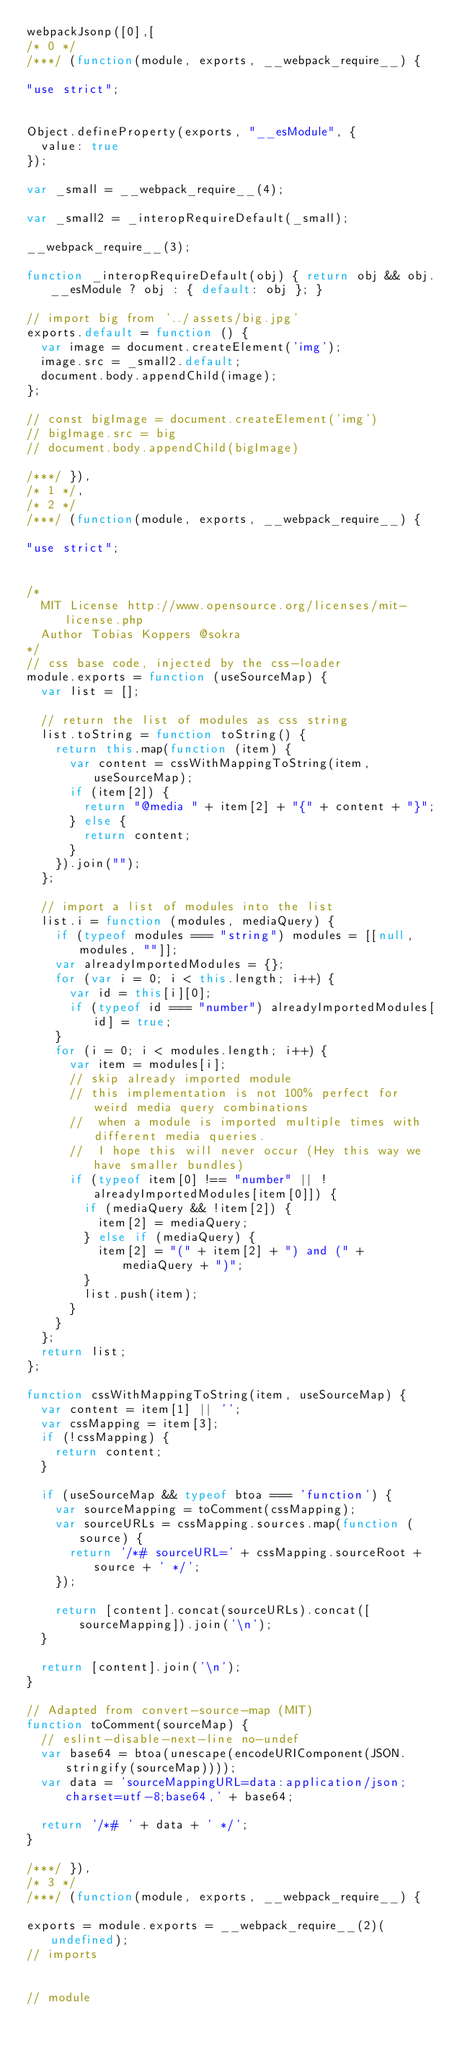<code> <loc_0><loc_0><loc_500><loc_500><_JavaScript_>webpackJsonp([0],[
/* 0 */
/***/ (function(module, exports, __webpack_require__) {

"use strict";


Object.defineProperty(exports, "__esModule", {
  value: true
});

var _small = __webpack_require__(4);

var _small2 = _interopRequireDefault(_small);

__webpack_require__(3);

function _interopRequireDefault(obj) { return obj && obj.__esModule ? obj : { default: obj }; }

// import big from '../assets/big.jpg'
exports.default = function () {
  var image = document.createElement('img');
  image.src = _small2.default;
  document.body.appendChild(image);
};

// const bigImage = document.createElement('img')
// bigImage.src = big
// document.body.appendChild(bigImage)

/***/ }),
/* 1 */,
/* 2 */
/***/ (function(module, exports, __webpack_require__) {

"use strict";


/*
	MIT License http://www.opensource.org/licenses/mit-license.php
	Author Tobias Koppers @sokra
*/
// css base code, injected by the css-loader
module.exports = function (useSourceMap) {
	var list = [];

	// return the list of modules as css string
	list.toString = function toString() {
		return this.map(function (item) {
			var content = cssWithMappingToString(item, useSourceMap);
			if (item[2]) {
				return "@media " + item[2] + "{" + content + "}";
			} else {
				return content;
			}
		}).join("");
	};

	// import a list of modules into the list
	list.i = function (modules, mediaQuery) {
		if (typeof modules === "string") modules = [[null, modules, ""]];
		var alreadyImportedModules = {};
		for (var i = 0; i < this.length; i++) {
			var id = this[i][0];
			if (typeof id === "number") alreadyImportedModules[id] = true;
		}
		for (i = 0; i < modules.length; i++) {
			var item = modules[i];
			// skip already imported module
			// this implementation is not 100% perfect for weird media query combinations
			//  when a module is imported multiple times with different media queries.
			//  I hope this will never occur (Hey this way we have smaller bundles)
			if (typeof item[0] !== "number" || !alreadyImportedModules[item[0]]) {
				if (mediaQuery && !item[2]) {
					item[2] = mediaQuery;
				} else if (mediaQuery) {
					item[2] = "(" + item[2] + ") and (" + mediaQuery + ")";
				}
				list.push(item);
			}
		}
	};
	return list;
};

function cssWithMappingToString(item, useSourceMap) {
	var content = item[1] || '';
	var cssMapping = item[3];
	if (!cssMapping) {
		return content;
	}

	if (useSourceMap && typeof btoa === 'function') {
		var sourceMapping = toComment(cssMapping);
		var sourceURLs = cssMapping.sources.map(function (source) {
			return '/*# sourceURL=' + cssMapping.sourceRoot + source + ' */';
		});

		return [content].concat(sourceURLs).concat([sourceMapping]).join('\n');
	}

	return [content].join('\n');
}

// Adapted from convert-source-map (MIT)
function toComment(sourceMap) {
	// eslint-disable-next-line no-undef
	var base64 = btoa(unescape(encodeURIComponent(JSON.stringify(sourceMap))));
	var data = 'sourceMappingURL=data:application/json;charset=utf-8;base64,' + base64;

	return '/*# ' + data + ' */';
}

/***/ }),
/* 3 */
/***/ (function(module, exports, __webpack_require__) {

exports = module.exports = __webpack_require__(2)(undefined);
// imports


// module</code> 